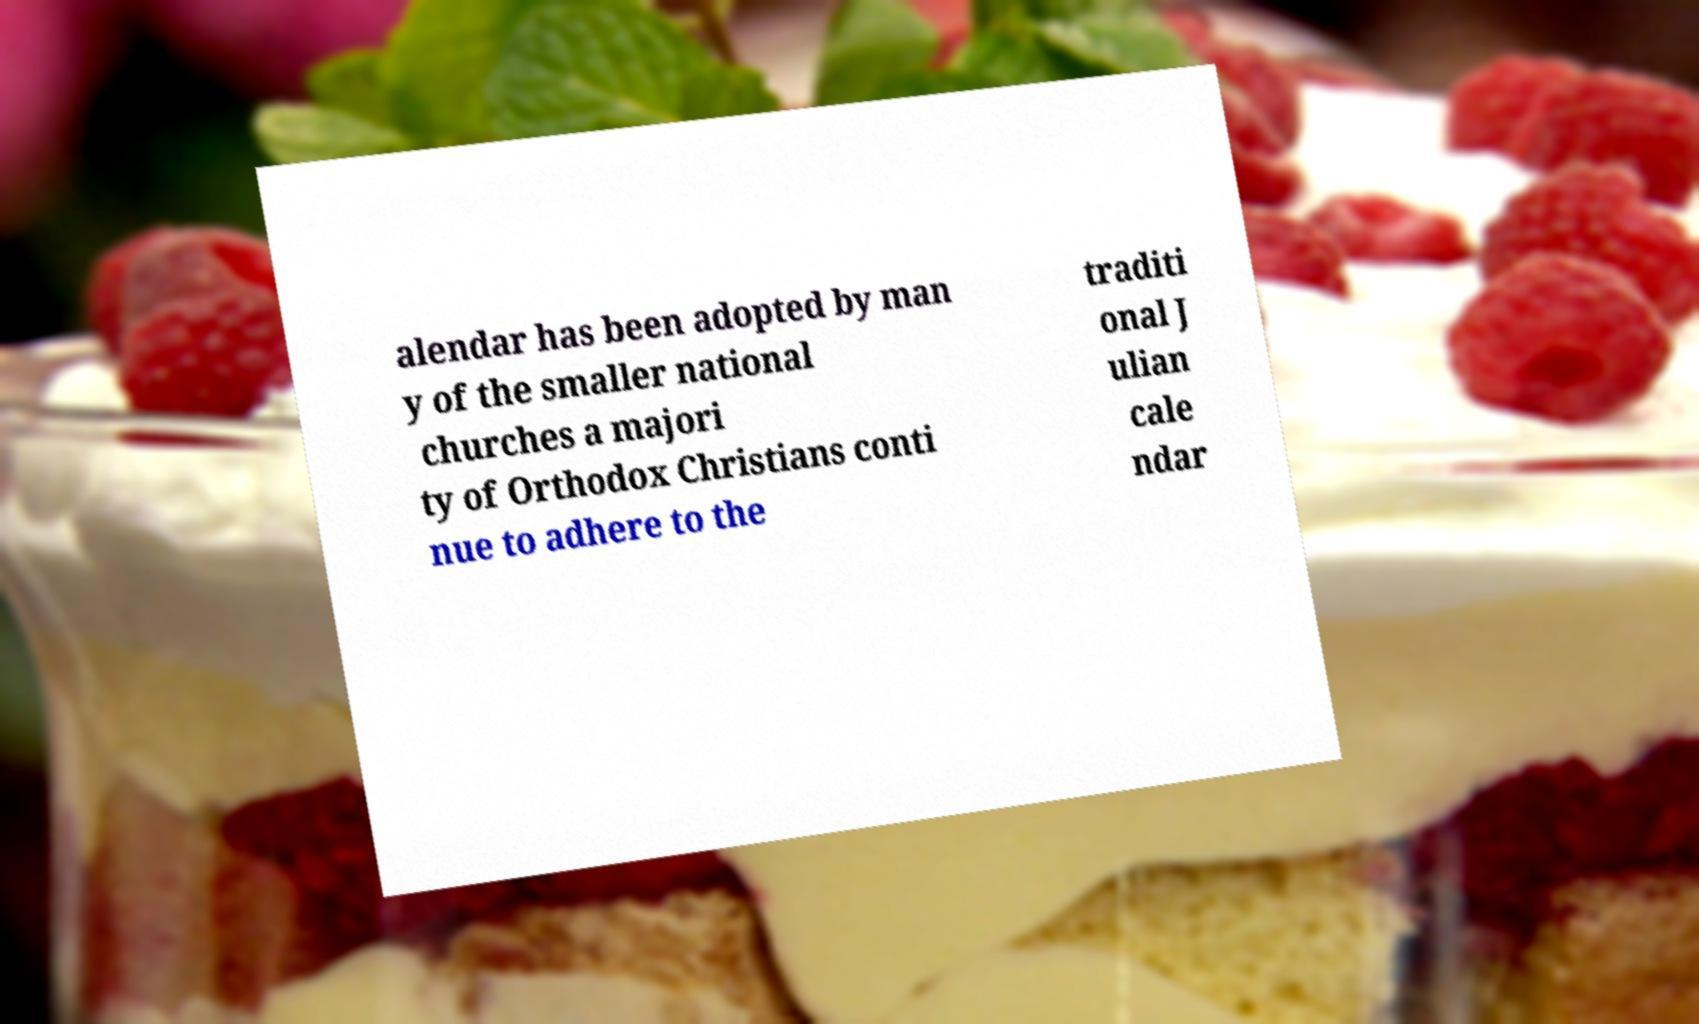I need the written content from this picture converted into text. Can you do that? alendar has been adopted by man y of the smaller national churches a majori ty of Orthodox Christians conti nue to adhere to the traditi onal J ulian cale ndar 